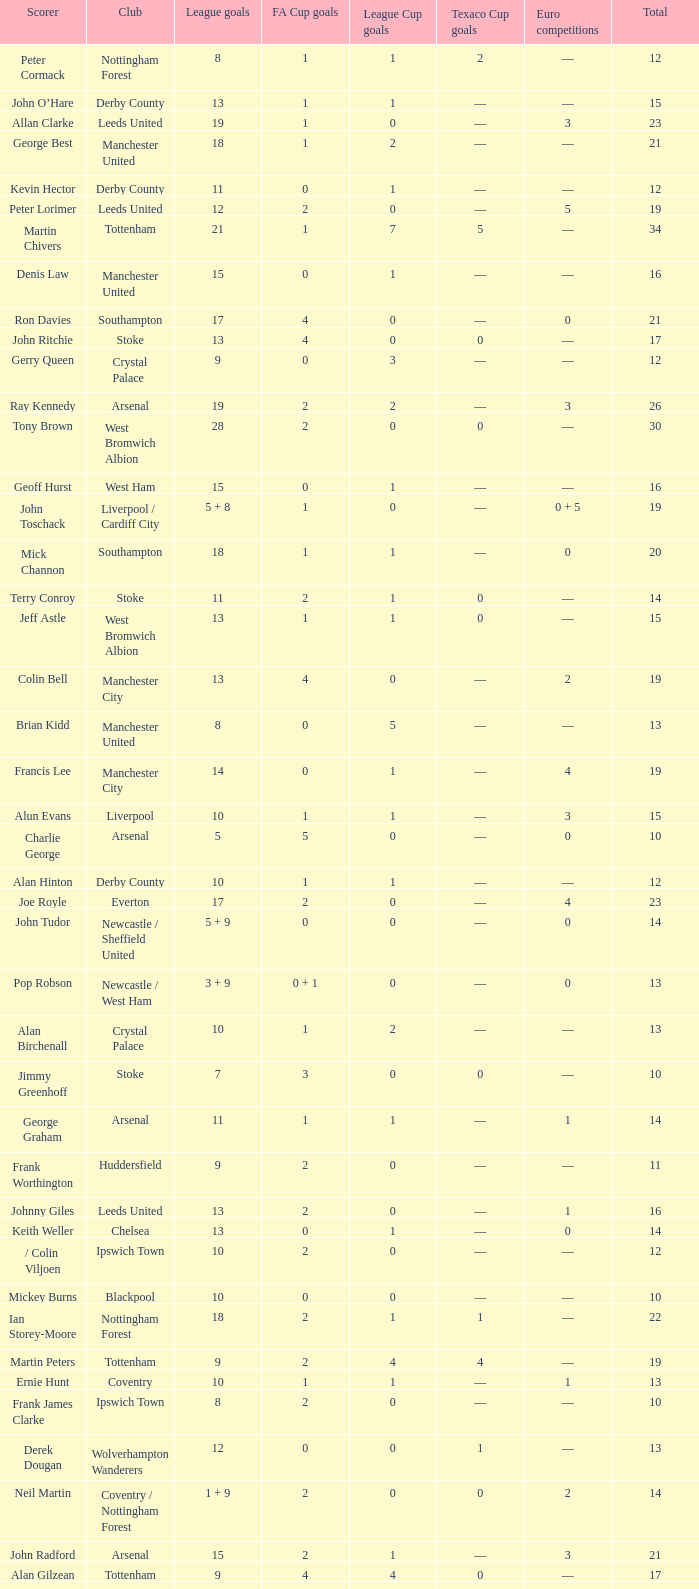What is the total number of Total, when Club is Leeds United, and when League Goals is 13? 1.0. 